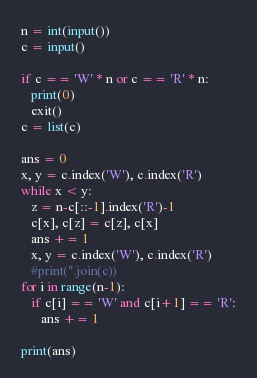Convert code to text. <code><loc_0><loc_0><loc_500><loc_500><_Python_>n = int(input())
c = input()

if c == 'W' * n or c == 'R' * n:
   print(0)
   exit()
c = list(c)

ans = 0
x, y = c.index('W'), c.index('R')
while x < y:
   z = n-c[::-1].index('R')-1
   c[x], c[z] = c[z], c[x]
   ans += 1
   x, y = c.index('W'), c.index('R')
   #print(''.join(c))
for i in range(n-1):
   if c[i] == 'W' and c[i+1] == 'R':
      ans += 1

print(ans)
</code> 